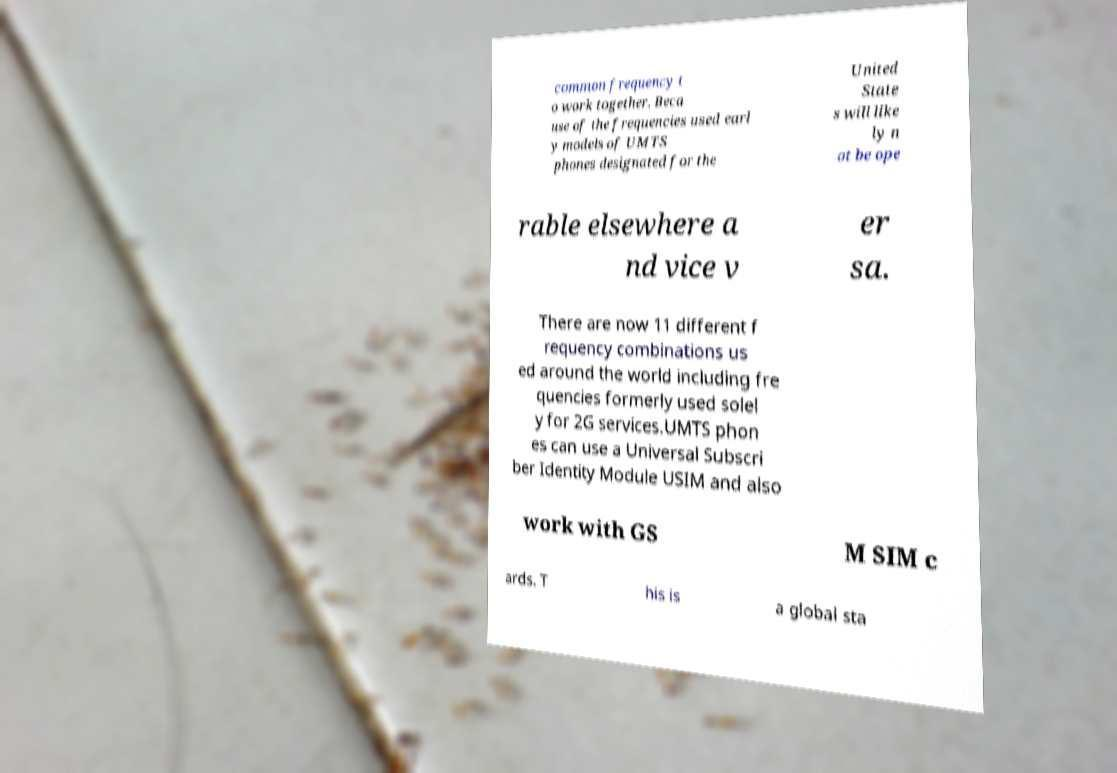Can you read and provide the text displayed in the image?This photo seems to have some interesting text. Can you extract and type it out for me? common frequency t o work together. Beca use of the frequencies used earl y models of UMTS phones designated for the United State s will like ly n ot be ope rable elsewhere a nd vice v er sa. There are now 11 different f requency combinations us ed around the world including fre quencies formerly used solel y for 2G services.UMTS phon es can use a Universal Subscri ber Identity Module USIM and also work with GS M SIM c ards. T his is a global sta 